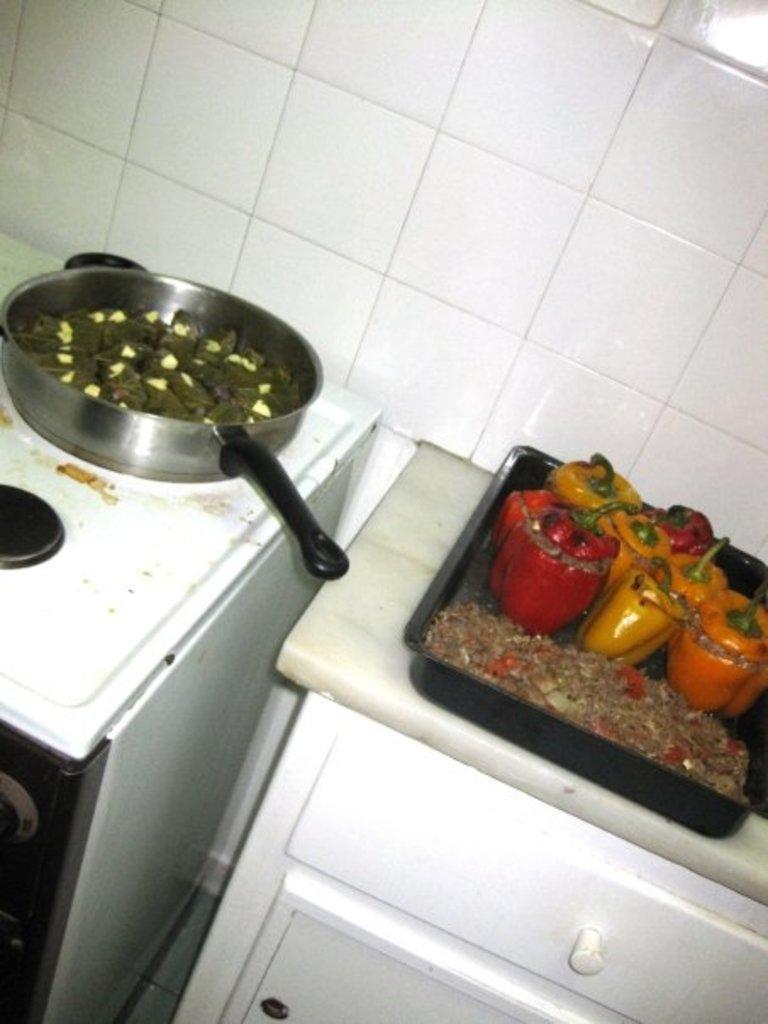Could you give a brief overview of what you see in this image? We can see tray with food and container on surface and we can see wall. 